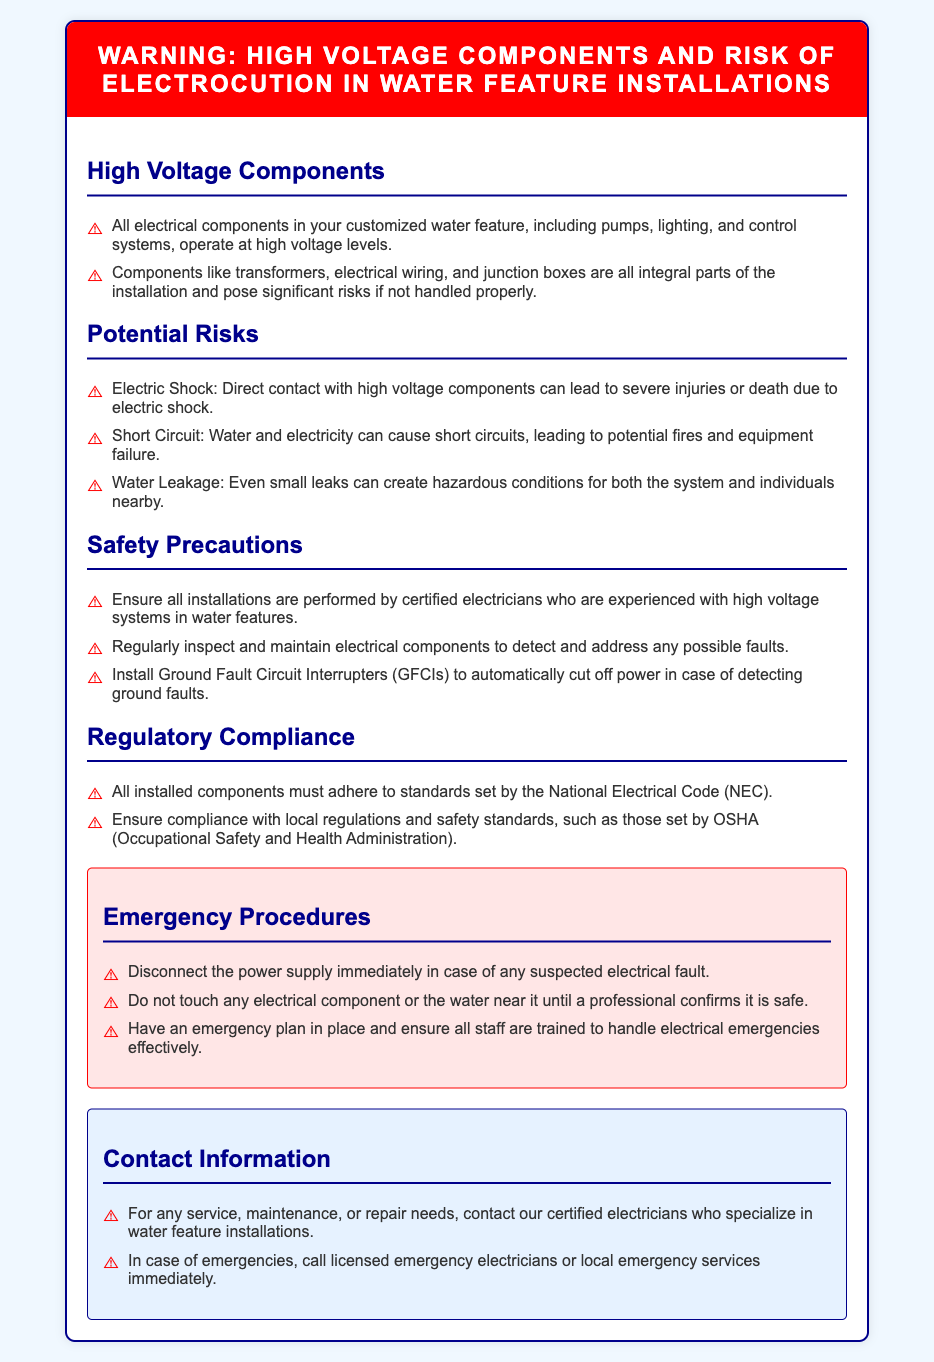What is the main hazard mentioned in the document? The document highlights that electric shock is a direct consequence of contact with high voltage components.
Answer: Electric shock Who should perform the installations? It is specified in the safety precautions that installations should be carried out by certified electricians experienced with high voltage systems.
Answer: Certified electricians What should be installed to cut off power in case of faults? The document notes that Ground Fault Circuit Interrupters (GFCIs) should be installed for safety.
Answer: Ground Fault Circuit Interrupters (GFCIs) What is one of the potential risks associated with water and electricity? A potential risk mentioned is that water and electricity can cause short circuits.
Answer: Short circuits Which regulatory code must all installed components adhere to? The document states that components must adhere to the standards set by the National Electrical Code (NEC).
Answer: National Electrical Code (NEC) What should be done immediately if an electrical fault is suspected? It is advised to disconnect the power supply immediately in case of any suspected electrical fault.
Answer: Disconnect the power supply What color is the header of the warning document? The header is highlighted in red to signify the warning nature of the document.
Answer: Red What training should all staff have according to the document? The document emphasizes that staff should be trained to handle electrical emergencies effectively.
Answer: Electrical emergencies training 